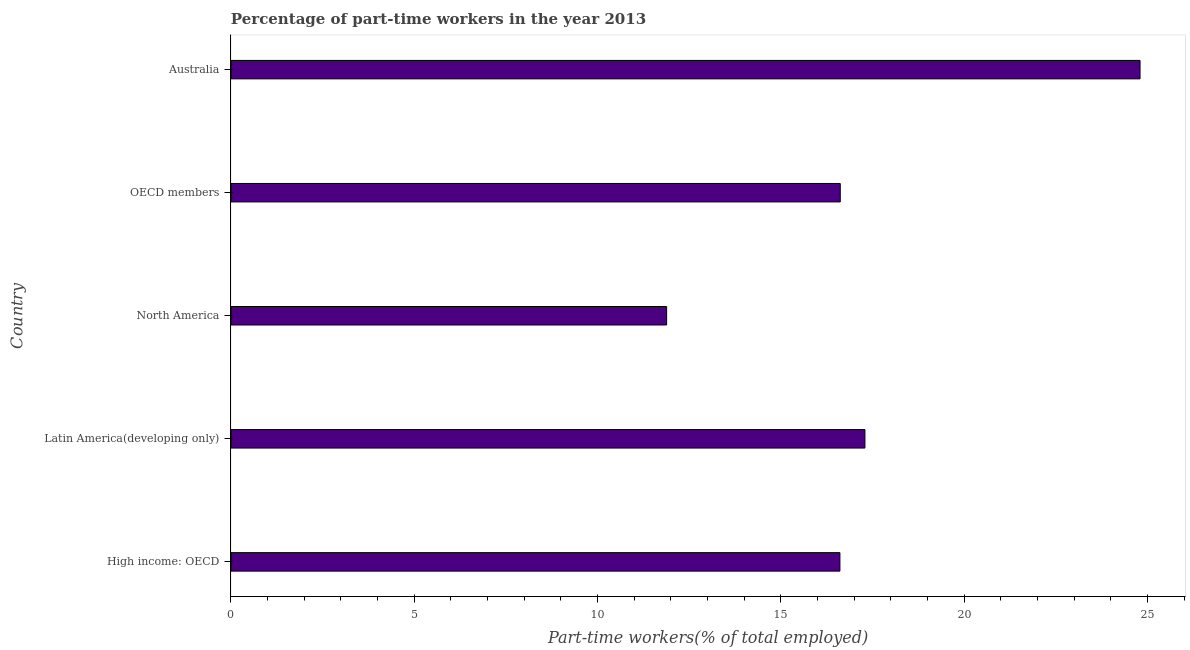Does the graph contain any zero values?
Provide a short and direct response. No. What is the title of the graph?
Make the answer very short. Percentage of part-time workers in the year 2013. What is the label or title of the X-axis?
Your answer should be compact. Part-time workers(% of total employed). What is the percentage of part-time workers in Australia?
Offer a terse response. 24.8. Across all countries, what is the maximum percentage of part-time workers?
Ensure brevity in your answer.  24.8. Across all countries, what is the minimum percentage of part-time workers?
Your response must be concise. 11.88. In which country was the percentage of part-time workers minimum?
Your answer should be very brief. North America. What is the sum of the percentage of part-time workers?
Keep it short and to the point. 87.21. What is the difference between the percentage of part-time workers in Australia and OECD members?
Provide a succinct answer. 8.18. What is the average percentage of part-time workers per country?
Your answer should be very brief. 17.44. What is the median percentage of part-time workers?
Provide a short and direct response. 16.62. What is the ratio of the percentage of part-time workers in North America to that in OECD members?
Offer a terse response. 0.71. Is the difference between the percentage of part-time workers in Australia and Latin America(developing only) greater than the difference between any two countries?
Give a very brief answer. No. What is the difference between the highest and the second highest percentage of part-time workers?
Offer a terse response. 7.51. Is the sum of the percentage of part-time workers in Australia and OECD members greater than the maximum percentage of part-time workers across all countries?
Make the answer very short. Yes. What is the difference between the highest and the lowest percentage of part-time workers?
Offer a very short reply. 12.92. In how many countries, is the percentage of part-time workers greater than the average percentage of part-time workers taken over all countries?
Offer a very short reply. 1. How many bars are there?
Your answer should be compact. 5. Are all the bars in the graph horizontal?
Keep it short and to the point. Yes. How many countries are there in the graph?
Offer a terse response. 5. What is the difference between two consecutive major ticks on the X-axis?
Your answer should be very brief. 5. Are the values on the major ticks of X-axis written in scientific E-notation?
Your answer should be very brief. No. What is the Part-time workers(% of total employed) in High income: OECD?
Provide a succinct answer. 16.61. What is the Part-time workers(% of total employed) in Latin America(developing only)?
Give a very brief answer. 17.29. What is the Part-time workers(% of total employed) of North America?
Keep it short and to the point. 11.88. What is the Part-time workers(% of total employed) in OECD members?
Provide a short and direct response. 16.62. What is the Part-time workers(% of total employed) in Australia?
Provide a succinct answer. 24.8. What is the difference between the Part-time workers(% of total employed) in High income: OECD and Latin America(developing only)?
Your answer should be very brief. -0.68. What is the difference between the Part-time workers(% of total employed) in High income: OECD and North America?
Your response must be concise. 4.73. What is the difference between the Part-time workers(% of total employed) in High income: OECD and OECD members?
Make the answer very short. -0.01. What is the difference between the Part-time workers(% of total employed) in High income: OECD and Australia?
Make the answer very short. -8.19. What is the difference between the Part-time workers(% of total employed) in Latin America(developing only) and North America?
Your response must be concise. 5.41. What is the difference between the Part-time workers(% of total employed) in Latin America(developing only) and OECD members?
Keep it short and to the point. 0.67. What is the difference between the Part-time workers(% of total employed) in Latin America(developing only) and Australia?
Provide a short and direct response. -7.51. What is the difference between the Part-time workers(% of total employed) in North America and OECD members?
Make the answer very short. -4.74. What is the difference between the Part-time workers(% of total employed) in North America and Australia?
Your answer should be very brief. -12.92. What is the difference between the Part-time workers(% of total employed) in OECD members and Australia?
Make the answer very short. -8.18. What is the ratio of the Part-time workers(% of total employed) in High income: OECD to that in Latin America(developing only)?
Provide a short and direct response. 0.96. What is the ratio of the Part-time workers(% of total employed) in High income: OECD to that in North America?
Your answer should be very brief. 1.4. What is the ratio of the Part-time workers(% of total employed) in High income: OECD to that in Australia?
Your answer should be compact. 0.67. What is the ratio of the Part-time workers(% of total employed) in Latin America(developing only) to that in North America?
Provide a succinct answer. 1.46. What is the ratio of the Part-time workers(% of total employed) in Latin America(developing only) to that in OECD members?
Your answer should be compact. 1.04. What is the ratio of the Part-time workers(% of total employed) in Latin America(developing only) to that in Australia?
Your response must be concise. 0.7. What is the ratio of the Part-time workers(% of total employed) in North America to that in OECD members?
Provide a succinct answer. 0.71. What is the ratio of the Part-time workers(% of total employed) in North America to that in Australia?
Provide a succinct answer. 0.48. What is the ratio of the Part-time workers(% of total employed) in OECD members to that in Australia?
Provide a short and direct response. 0.67. 